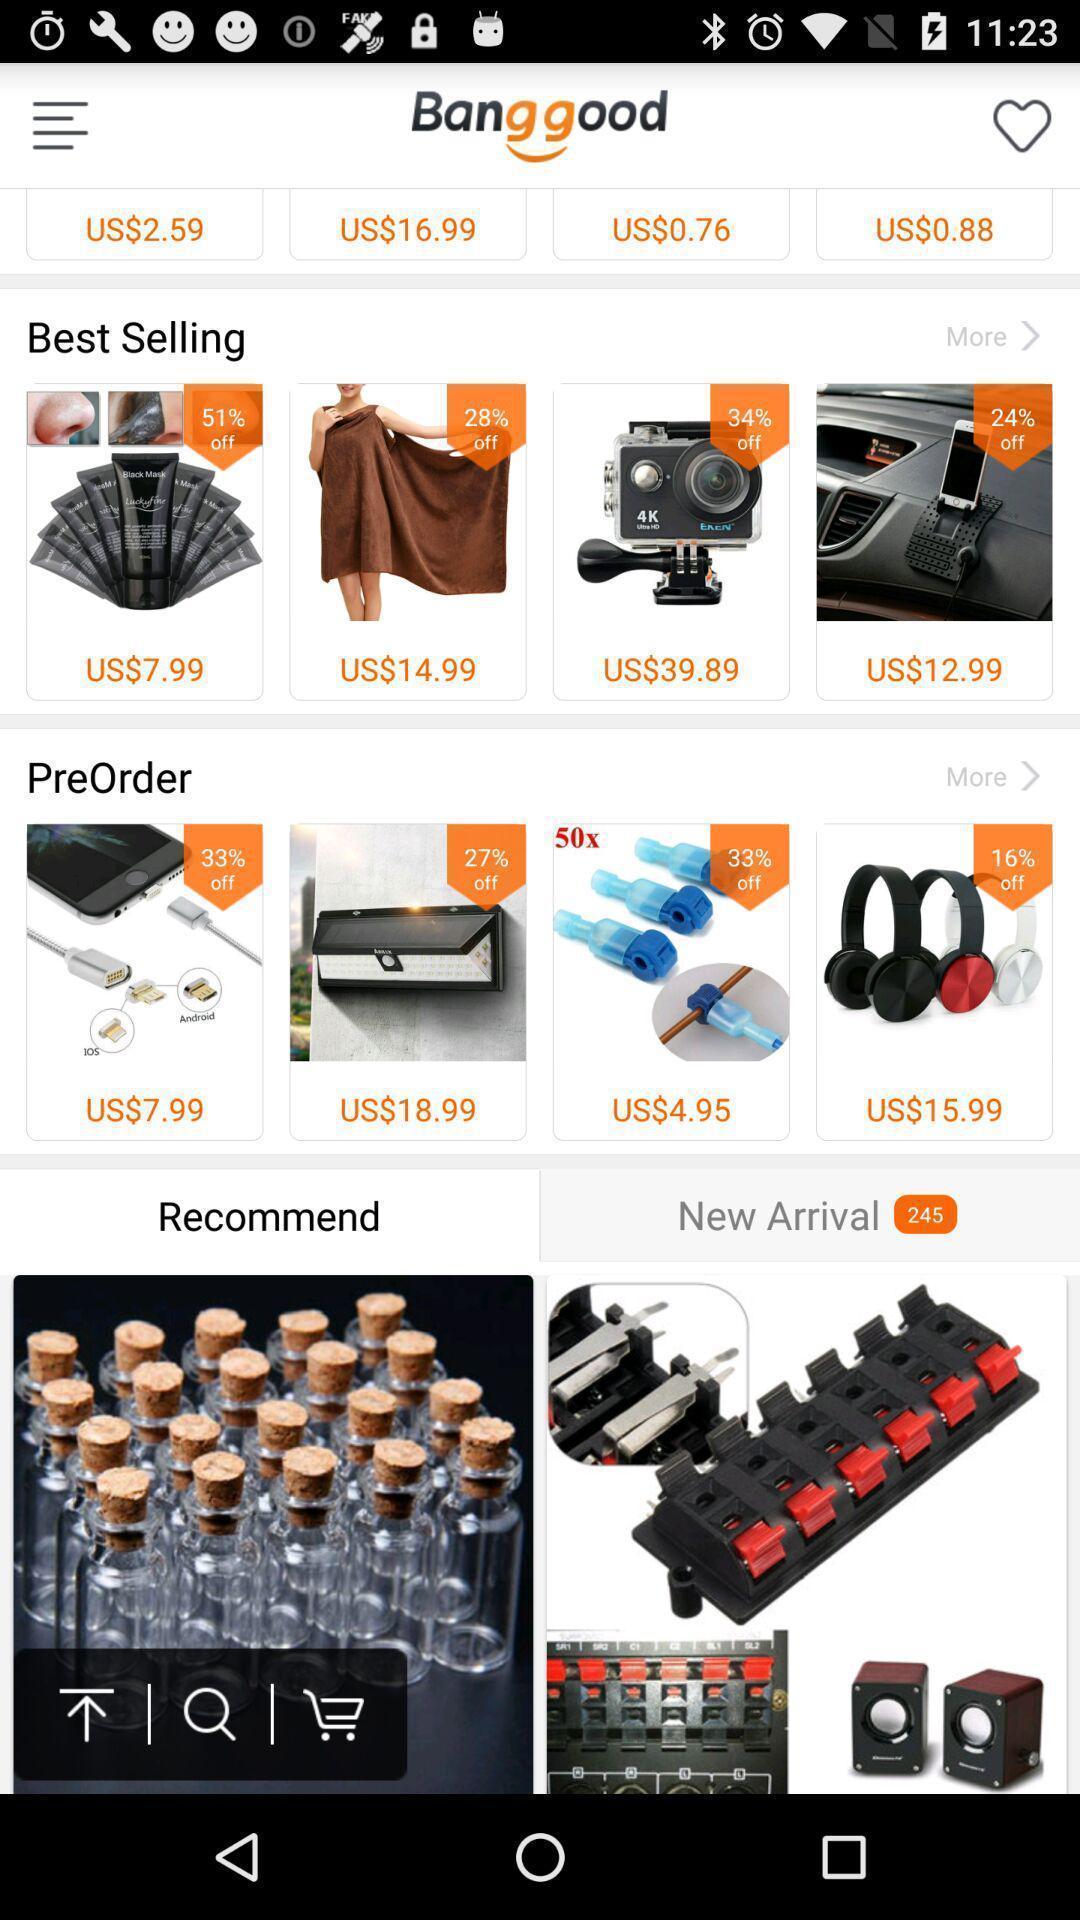Describe the content in this image. Page showing the items in shopping app. 